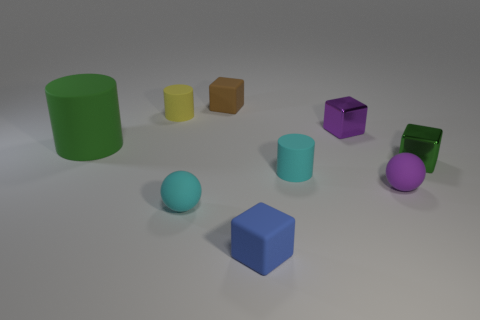Subtract 1 cubes. How many cubes are left? 3 Subtract all blocks. How many objects are left? 5 Add 8 tiny yellow rubber objects. How many tiny yellow rubber objects are left? 9 Add 5 yellow matte things. How many yellow matte things exist? 6 Subtract 1 green cylinders. How many objects are left? 8 Subtract all tiny things. Subtract all gray metallic cylinders. How many objects are left? 1 